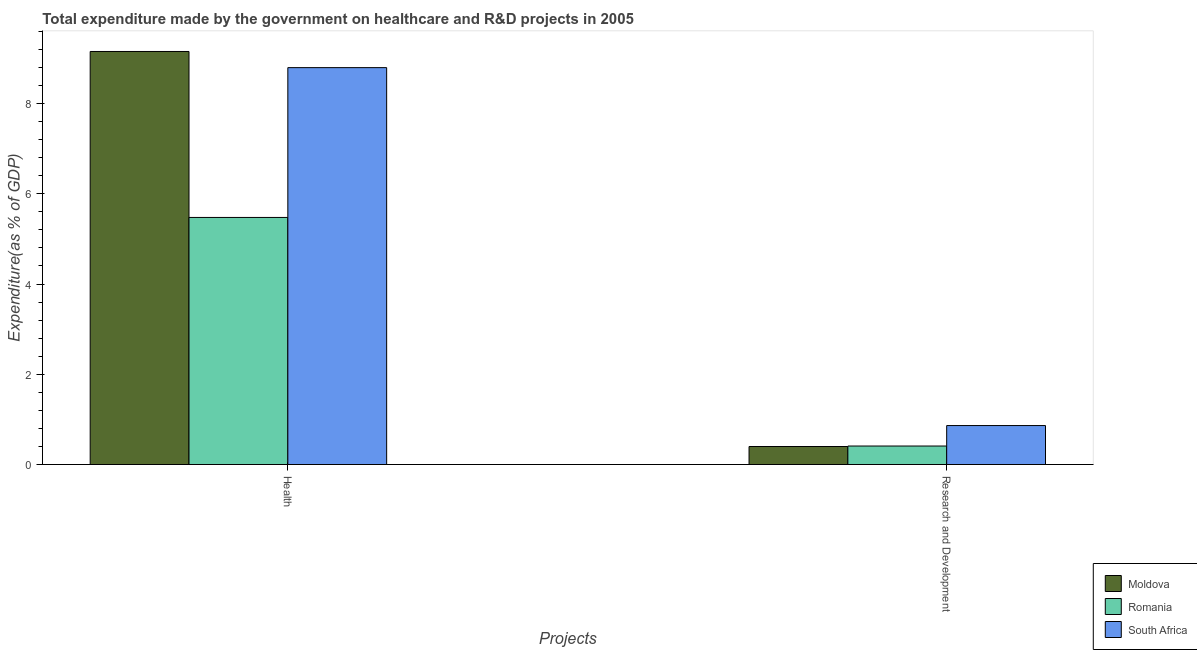How many different coloured bars are there?
Make the answer very short. 3. Are the number of bars on each tick of the X-axis equal?
Offer a very short reply. Yes. How many bars are there on the 2nd tick from the right?
Offer a terse response. 3. What is the label of the 1st group of bars from the left?
Offer a very short reply. Health. What is the expenditure in r&d in Romania?
Your answer should be compact. 0.41. Across all countries, what is the maximum expenditure in r&d?
Your answer should be compact. 0.86. Across all countries, what is the minimum expenditure in healthcare?
Your answer should be compact. 5.48. In which country was the expenditure in healthcare maximum?
Provide a short and direct response. Moldova. In which country was the expenditure in r&d minimum?
Make the answer very short. Moldova. What is the total expenditure in r&d in the graph?
Your response must be concise. 1.67. What is the difference between the expenditure in r&d in Romania and that in South Africa?
Ensure brevity in your answer.  -0.45. What is the difference between the expenditure in healthcare in South Africa and the expenditure in r&d in Moldova?
Keep it short and to the point. 8.4. What is the average expenditure in healthcare per country?
Offer a very short reply. 7.81. What is the difference between the expenditure in healthcare and expenditure in r&d in Moldova?
Your response must be concise. 8.75. What is the ratio of the expenditure in healthcare in Moldova to that in Romania?
Offer a very short reply. 1.67. Is the expenditure in healthcare in South Africa less than that in Moldova?
Make the answer very short. Yes. What does the 1st bar from the left in Health represents?
Your answer should be very brief. Moldova. What does the 3rd bar from the right in Research and Development represents?
Your answer should be very brief. Moldova. Are all the bars in the graph horizontal?
Ensure brevity in your answer.  No. How many countries are there in the graph?
Keep it short and to the point. 3. Does the graph contain any zero values?
Provide a succinct answer. No. Where does the legend appear in the graph?
Your answer should be very brief. Bottom right. How are the legend labels stacked?
Provide a succinct answer. Vertical. What is the title of the graph?
Give a very brief answer. Total expenditure made by the government on healthcare and R&D projects in 2005. What is the label or title of the X-axis?
Offer a terse response. Projects. What is the label or title of the Y-axis?
Your response must be concise. Expenditure(as % of GDP). What is the Expenditure(as % of GDP) of Moldova in Health?
Your answer should be very brief. 9.15. What is the Expenditure(as % of GDP) in Romania in Health?
Make the answer very short. 5.48. What is the Expenditure(as % of GDP) in South Africa in Health?
Provide a succinct answer. 8.8. What is the Expenditure(as % of GDP) in Moldova in Research and Development?
Offer a terse response. 0.4. What is the Expenditure(as % of GDP) in Romania in Research and Development?
Offer a very short reply. 0.41. What is the Expenditure(as % of GDP) in South Africa in Research and Development?
Give a very brief answer. 0.86. Across all Projects, what is the maximum Expenditure(as % of GDP) of Moldova?
Make the answer very short. 9.15. Across all Projects, what is the maximum Expenditure(as % of GDP) of Romania?
Keep it short and to the point. 5.48. Across all Projects, what is the maximum Expenditure(as % of GDP) of South Africa?
Offer a very short reply. 8.8. Across all Projects, what is the minimum Expenditure(as % of GDP) in Moldova?
Your response must be concise. 0.4. Across all Projects, what is the minimum Expenditure(as % of GDP) in Romania?
Your answer should be compact. 0.41. Across all Projects, what is the minimum Expenditure(as % of GDP) of South Africa?
Keep it short and to the point. 0.86. What is the total Expenditure(as % of GDP) in Moldova in the graph?
Offer a terse response. 9.55. What is the total Expenditure(as % of GDP) of Romania in the graph?
Offer a terse response. 5.88. What is the total Expenditure(as % of GDP) of South Africa in the graph?
Your answer should be very brief. 9.66. What is the difference between the Expenditure(as % of GDP) in Moldova in Health and that in Research and Development?
Keep it short and to the point. 8.75. What is the difference between the Expenditure(as % of GDP) in Romania in Health and that in Research and Development?
Make the answer very short. 5.07. What is the difference between the Expenditure(as % of GDP) in South Africa in Health and that in Research and Development?
Your answer should be compact. 7.93. What is the difference between the Expenditure(as % of GDP) of Moldova in Health and the Expenditure(as % of GDP) of Romania in Research and Development?
Your response must be concise. 8.74. What is the difference between the Expenditure(as % of GDP) in Moldova in Health and the Expenditure(as % of GDP) in South Africa in Research and Development?
Make the answer very short. 8.29. What is the difference between the Expenditure(as % of GDP) of Romania in Health and the Expenditure(as % of GDP) of South Africa in Research and Development?
Provide a short and direct response. 4.61. What is the average Expenditure(as % of GDP) in Moldova per Projects?
Offer a terse response. 4.78. What is the average Expenditure(as % of GDP) of Romania per Projects?
Offer a very short reply. 2.94. What is the average Expenditure(as % of GDP) of South Africa per Projects?
Keep it short and to the point. 4.83. What is the difference between the Expenditure(as % of GDP) of Moldova and Expenditure(as % of GDP) of Romania in Health?
Provide a succinct answer. 3.68. What is the difference between the Expenditure(as % of GDP) in Moldova and Expenditure(as % of GDP) in South Africa in Health?
Provide a succinct answer. 0.36. What is the difference between the Expenditure(as % of GDP) in Romania and Expenditure(as % of GDP) in South Africa in Health?
Provide a succinct answer. -3.32. What is the difference between the Expenditure(as % of GDP) of Moldova and Expenditure(as % of GDP) of Romania in Research and Development?
Your answer should be compact. -0.01. What is the difference between the Expenditure(as % of GDP) of Moldova and Expenditure(as % of GDP) of South Africa in Research and Development?
Your response must be concise. -0.46. What is the difference between the Expenditure(as % of GDP) in Romania and Expenditure(as % of GDP) in South Africa in Research and Development?
Make the answer very short. -0.45. What is the ratio of the Expenditure(as % of GDP) of Moldova in Health to that in Research and Development?
Keep it short and to the point. 22.96. What is the ratio of the Expenditure(as % of GDP) of Romania in Health to that in Research and Development?
Offer a very short reply. 13.37. What is the ratio of the Expenditure(as % of GDP) of South Africa in Health to that in Research and Development?
Your response must be concise. 10.19. What is the difference between the highest and the second highest Expenditure(as % of GDP) in Moldova?
Keep it short and to the point. 8.75. What is the difference between the highest and the second highest Expenditure(as % of GDP) of Romania?
Your answer should be compact. 5.07. What is the difference between the highest and the second highest Expenditure(as % of GDP) of South Africa?
Provide a succinct answer. 7.93. What is the difference between the highest and the lowest Expenditure(as % of GDP) in Moldova?
Offer a very short reply. 8.75. What is the difference between the highest and the lowest Expenditure(as % of GDP) in Romania?
Make the answer very short. 5.07. What is the difference between the highest and the lowest Expenditure(as % of GDP) of South Africa?
Provide a succinct answer. 7.93. 